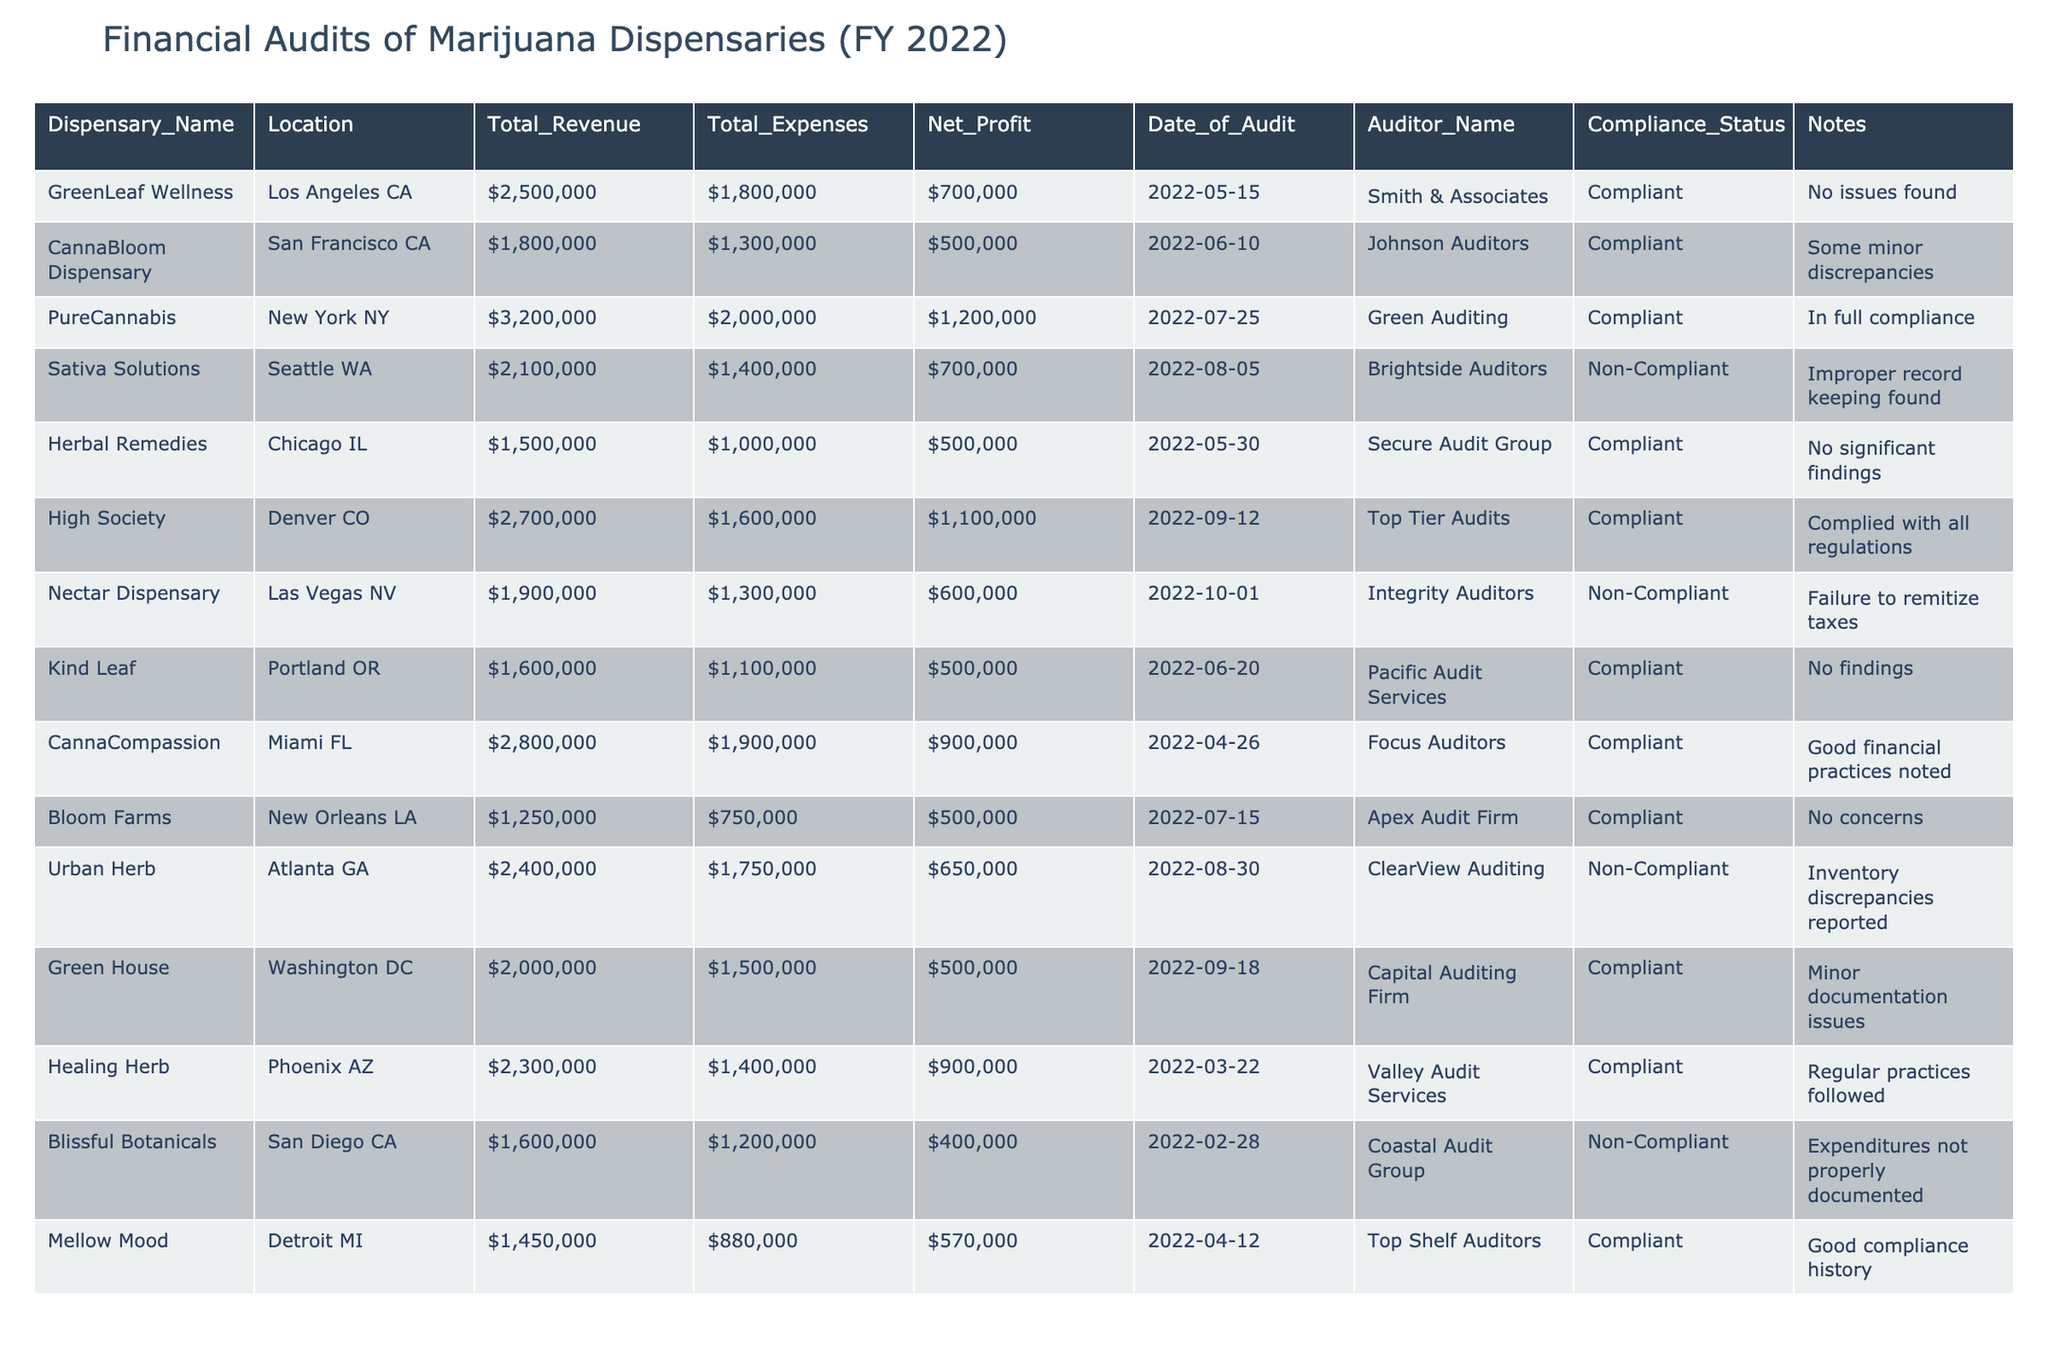What is the total revenue of PureCannabis? From the table, I can see the row for PureCannabis lists a "Total_Revenue" of $3,200,000.
Answer: $3,200,000 How many dispensaries reported as non-compliant? By reviewing the "Compliance_Status" column, I count the dispensaries marked as non-compliant: Sativa Solutions, Nectar Dispensary, Urban Herb, and Blissful Botanicals, which totals four dispensaries.
Answer: 4 What is the net profit of GreenLeaf Wellness? The net profit for GreenLeaf Wellness can be found in the corresponding row, which shows a "Net_Profit" of $700,000.
Answer: $700,000 Which dispensary has the highest total expenses? Analyzing the "Total_Expenses" column, PureCannabis has the highest total expenses listed at $2,000,000.
Answer: PureCannabis What was the compliance status of the dispensary located in Miami? Checking the "Location" column for Miami results in CannaCompassion, which has a "Compliance_Status" of Compliant.
Answer: Compliant What is the average net profit of the compliant dispensaries? I sum the net profits of compliant dispensaries: $700,000 (GreenLeaf) + $500,000 (CannaBloom) + $1,200,000 (PureCannabis) + $500,000 (Herbal Remedies) + $1,100,000 (High Society) + $900,000 (CannaCompassion) + $500,000 (Kind Leaf) + $500,000 (Bloom Farms) + $570,000 (Mellow Mood) = $6,170,000. There are 9 compliant dispensaries, so the average is $6,170,000 / 9 = $686,667.
Answer: $686,667 What issues were reported during the audit of Urban Herb? The notes for Urban Herb indicate "Inventory discrepancies reported," which highlights the issues found during their audit.
Answer: Inventory discrepancies Which state has the dispensary with the lowest total revenue, and what is that revenue? Bloom Farms in New Orleans LA has the lowest total revenue listed at $1,250,000. Therefore, the state is Louisiana, and the revenue is $1,250,000.
Answer: Louisiana, $1,250,000 How many dispensaries had issues found during their audits? By assessing the "Notes" for each dispensary, I find that Sativa Solutions, Nectar Dispensary, Urban Herb, and Blissful Botanicals had issues found, totaling four dispensaries.
Answer: 4 What is the total revenue for dispensaries located in California? The dispensaries in California are GreenLeaf Wellness ($2,500,000) and CannaBloom Dispensary ($1,800,000). The total revenue is $2,500,000 + $1,800,000 = $4,300,000.
Answer: $4,300,000 Which auditor handled the audit for Sativa Solutions? Looking at the row for Sativa Solutions, the auditor listed is Brightside Auditors.
Answer: Brightside Auditors 